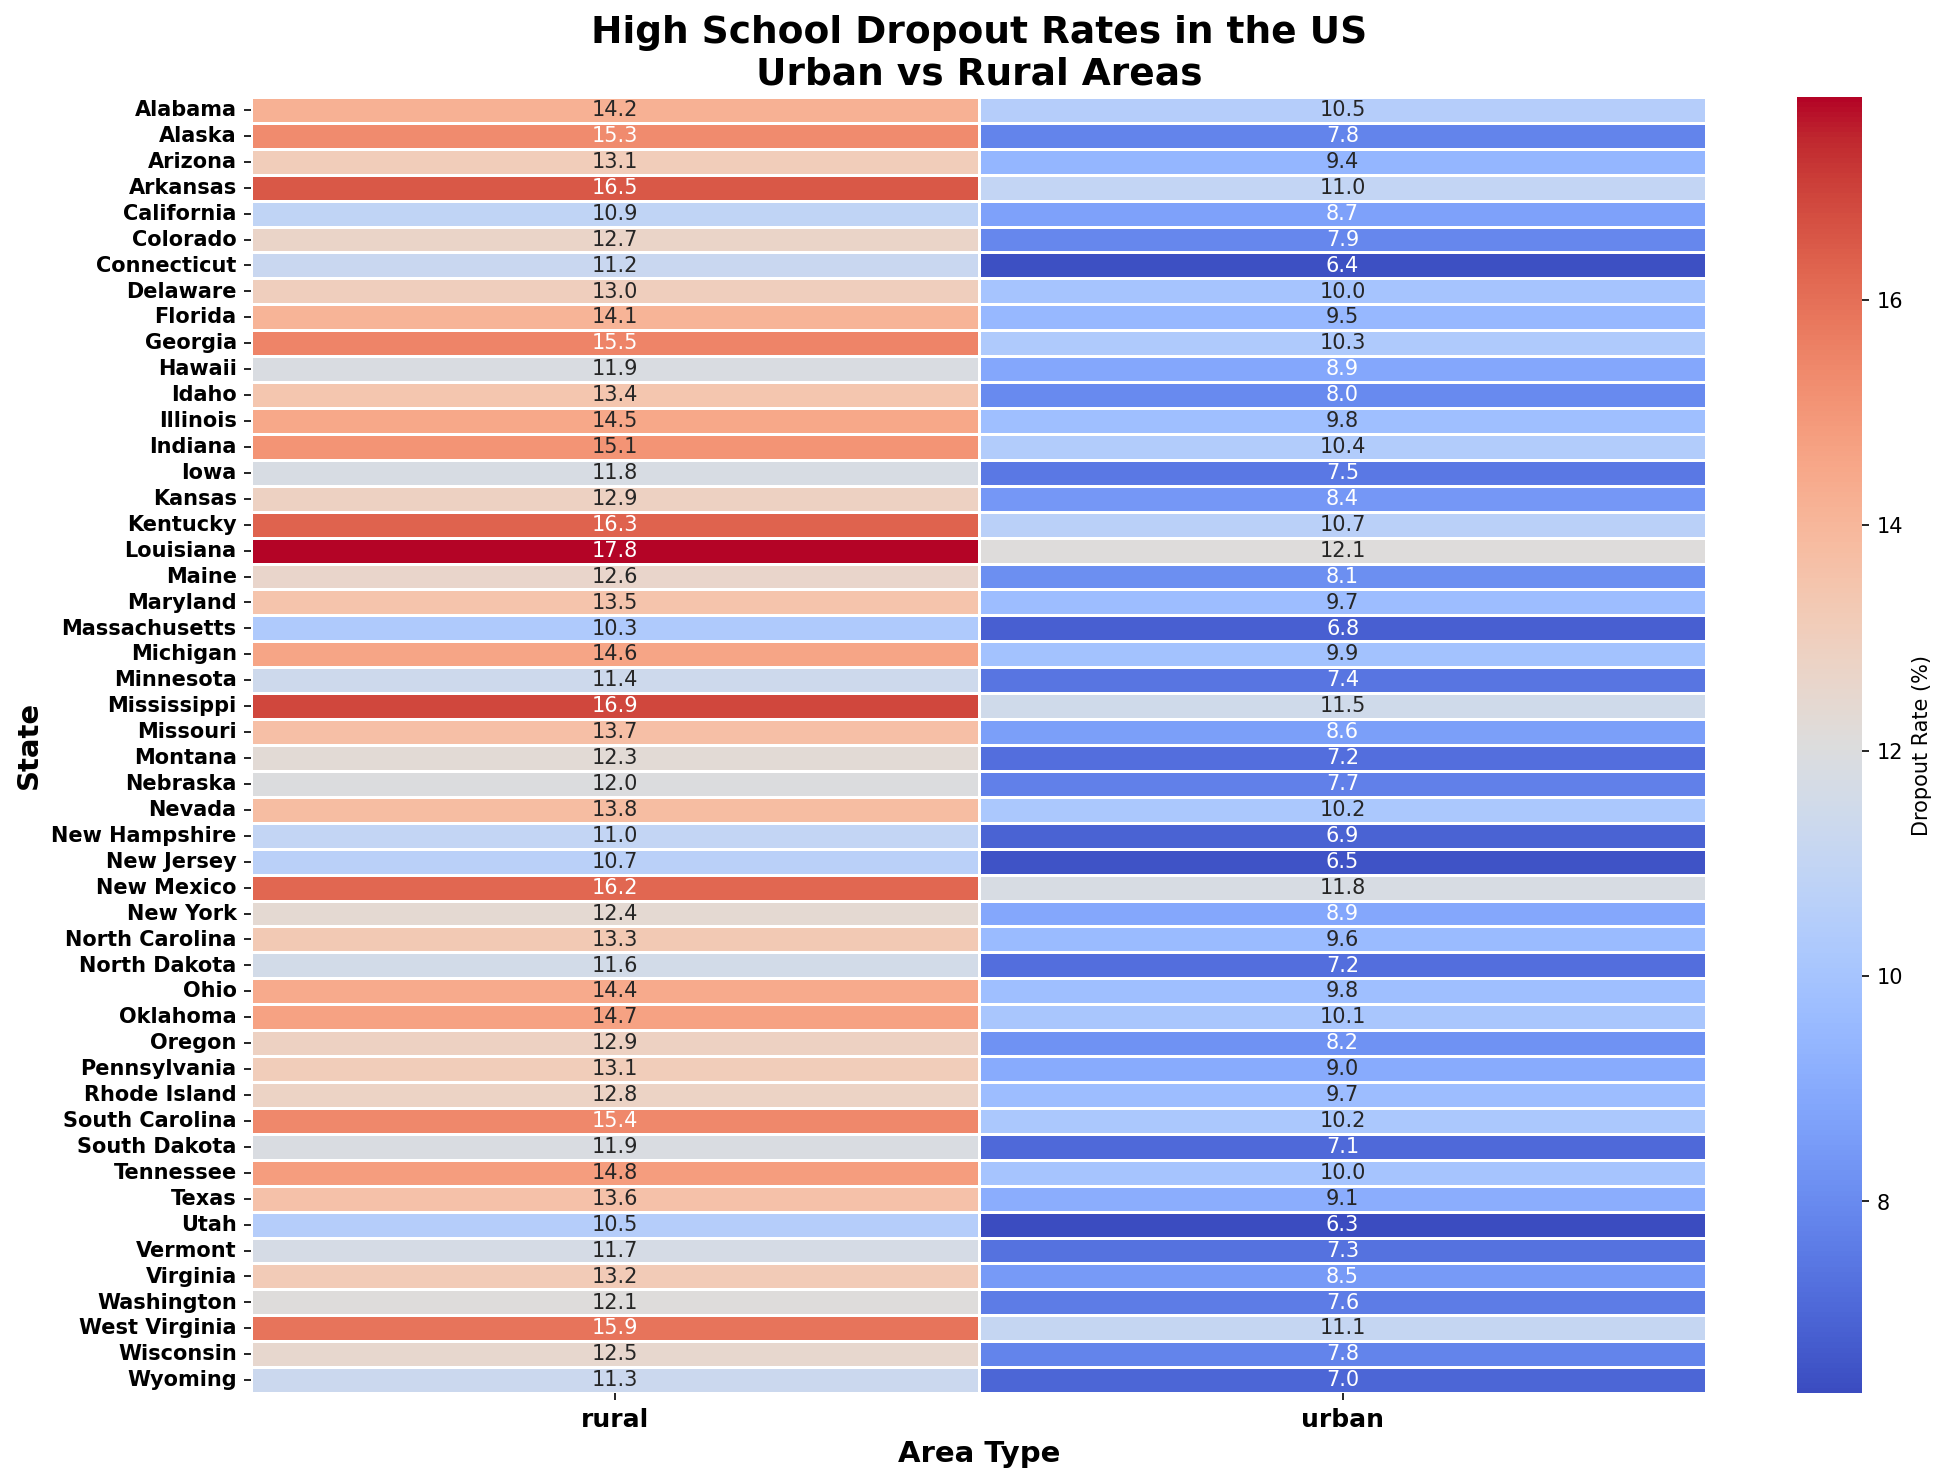Which state has the highest dropout rate in rural areas? To find the state with the highest dropout rate in rural areas, look at the column labeled 'rural' and identify the highest number. In this case, it's clear that Louisiana has the highest dropout rate of 17.8%.
Answer: Louisiana Which state has the lowest dropout rate in urban areas? To find the state with the lowest dropout rate in urban areas, look at the column labeled 'urban' and find the smallest number. The smallest number is 6.3%, which corresponds to Utah.
Answer: Utah What is the average dropout rate in urban areas across all states? Sum all the dropout rates in the urban column and then divide by the number of states. The total is 675.8, and there are 51 states, so the average dropout rate is 675.8 / 51 = 13.25%
Answer: 13.25% How much higher is the rural dropout rate in Alabama compared to the urban dropout rate? Subtract the urban dropout rate for Alabama from the rural dropout rate. That is 14.2% (rural) - 10.5% (urban) = 3.7%.
Answer: 3.7% Which states have a greater dropout rate in urban areas than in rural areas? Compare urban and rural dropout rates for each state and find where the urban rate is higher. No state from the provided data has a higher dropout rate in urban areas than in rural areas.
Answer: None What is the difference in dropout rates between urban and rural areas in Texas? Subtract the urban dropout rate for Texas from the rural dropout rate. That is 13.6% (rural) - 9.1% (urban) = 4.5%.
Answer: 4.5% How does the dropout rate of urban areas in California compare to urban areas in Florida? Compare the dropout rates directly: California's urban dropout rate is 8.7%, and Florida's is 9.5%. Therefore, Florida has a higher urban dropout rate than California.
Answer: Florida higher Which state has the closest rural and urban dropout rates, and what is the difference? Calculate the difference between rural and urban dropout rates for each state and find the smallest difference. Vermont has a difference of only 4.4% - 7.3% = 4.4%.
Answer: Vermont, 4.4% What is the median dropout rate for rural areas? Arrange the dropout rates in the 'rural' column in ascending order and find the middle value. For 51 states, the median is the 26th value. Make a list and pick the middle value. The middle value in this case is approximately 13.3%.
Answer: 13.3% Which states have rural dropout rates above 15% but urban dropout rates below 10%? Identify and compare the rural and urban dropout rates for each state. Louisiana, Mississippi, and New Mexico have rural dropout rates above 15% and urban dropout rates below 10%.
Answer: Louisiana, Mississippi, New Mexico 